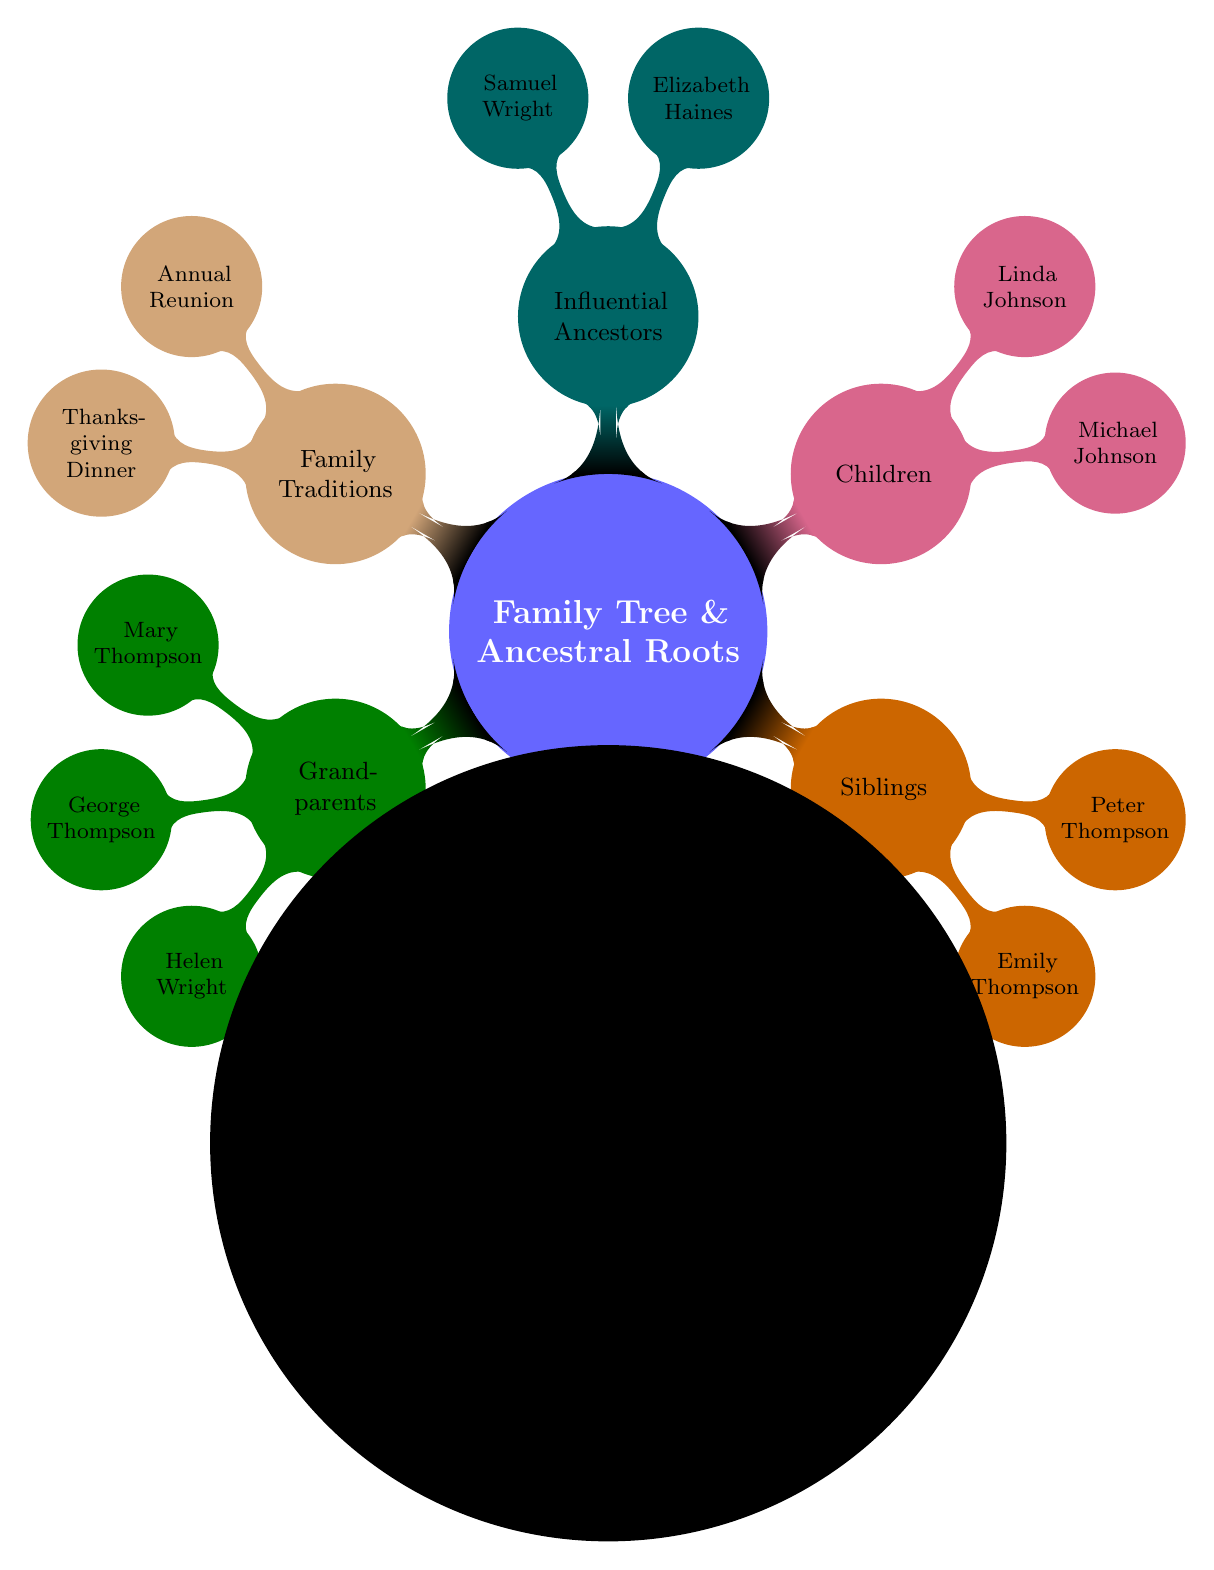What is the main node of the diagram? The main node is clearly stated at the top of the mind map, which is "Family Tree & Ancestral Roots".
Answer: Family Tree & Ancestral Roots How many grandparents are listed in the diagram? To find out, we count the subnodes under the "Grandparents" node, which include four names: Mary Thompson, George Thompson, Helen Wright, and Robert Wright.
Answer: 4 Who is the mother in the family tree? By examining the "Parents" node, we find that Alice Wright is identified as the mother.
Answer: Alice Wright What are the family traditions mentioned? The node labeled "Family Traditions" has two subnodes, namely "Annual Reunion at Grandmother's House" and "Thanksgiving Dinner Recipes," indicating the traditions of the family.
Answer: Annual Reunion at Grandmother's House, Thanksgiving Dinner Recipes Which node contains siblings? The "Siblings" node explicitly lists who the siblings are, identifying the node as having the subnodes Emily Thompson and Peter Thompson.
Answer: Siblings How many children does the family have? By looking at the "Children" node, we note there are two subnodes, Michael Johnson and Linda Johnson, determining the total count.
Answer: 2 Who are the influential ancestors listed in the family tree? The "Influential Ancestors" node contains two names: Elizabeth Haines and Samuel Wright, directly answering the inquiry about influential family members.
Answer: Elizabeth Haines, Samuel Wright What is the relationship between Alice Wright and Michael Johnson? Between the "Parents" and "Children" nodes, it can be inferred that Alice Wright is the mother of Michael Johnson, establishing a familial relationship.
Answer: Mother Which node would contain the paternal grandparents? The "Grandparents" node would specify the paternal grandparents, which include Helen Wright and Robert Wright, clearly segregating maternal and paternal sides.
Answer: Grandparents 